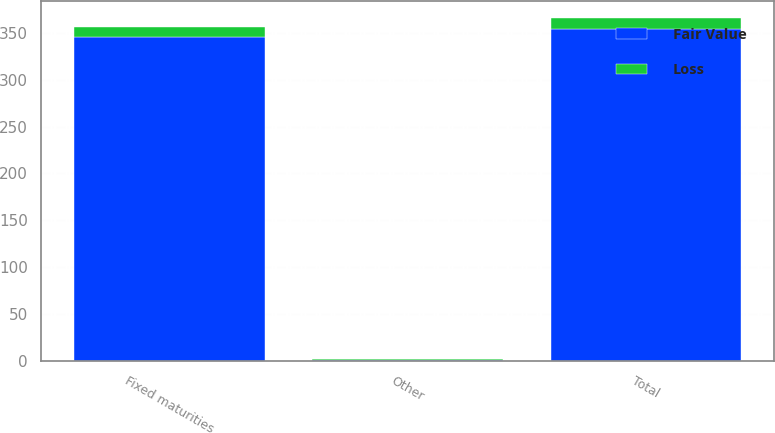Convert chart. <chart><loc_0><loc_0><loc_500><loc_500><stacked_bar_chart><ecel><fcel>Fixed maturities<fcel>Other<fcel>Total<nl><fcel>Loss<fcel>11<fcel>1<fcel>12<nl><fcel>Fair Value<fcel>345<fcel>1<fcel>354<nl></chart> 